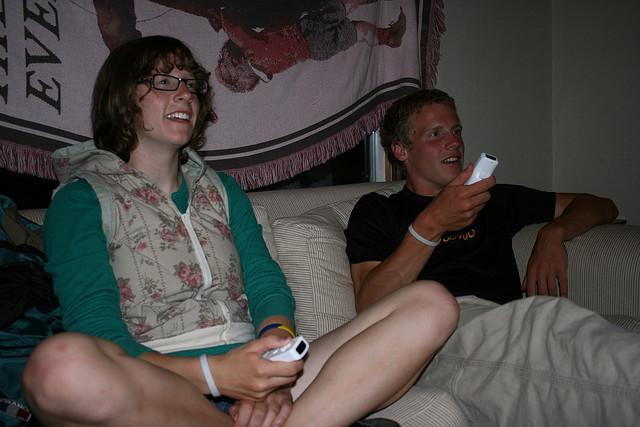Is she wearing glasses?
Give a very brief answer. Yes. IS she wearing formal or sporty attire?
Write a very short answer. Sporty. What are the colors of her spread?
Quick response, please. White. Does it seem as if the action being watched is rather high up?
Give a very brief answer. Yes. How many people are in this picture?
Write a very short answer. 2. What gaming console are they using?
Give a very brief answer. Wii. Is she trying to put a child to sleep?
Short answer required. No. Are they likely to be a couple?
Quick response, please. Yes. 